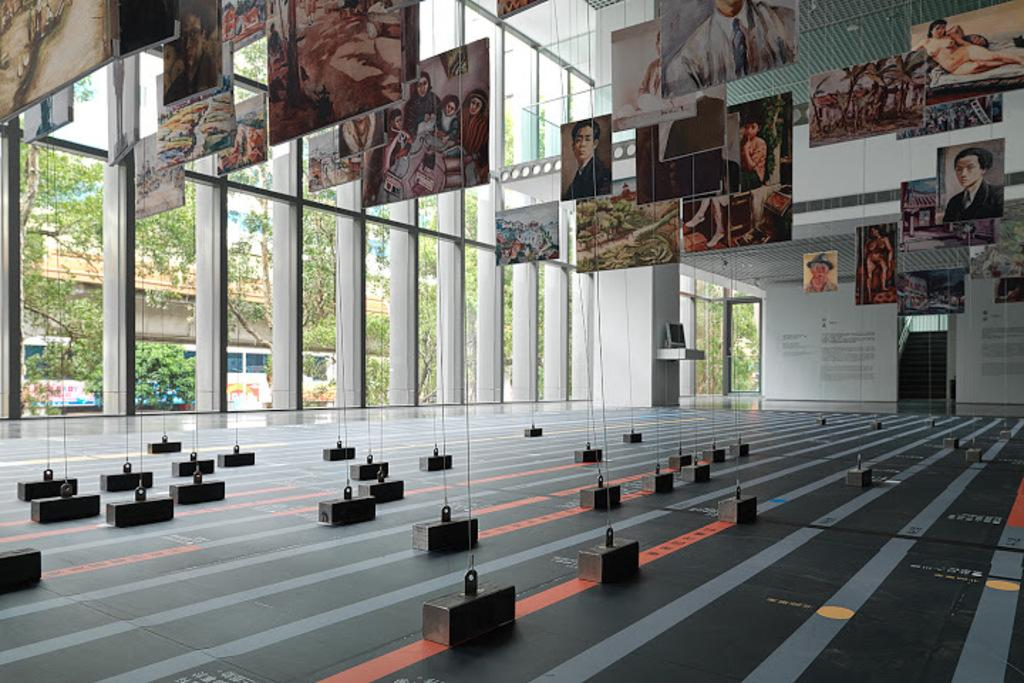What objects are hanging from the ceiling in the image? There are weights hanging from the ceiling in the image. Where are the weights located in relation to the floor? The weights are on the floor in the image. What type of artwork can be seen in the image? There are paintings hanging in the image. What type of windows are present in the image? There are glass windows in the image. What can be seen through the glass windows? Trees are visible behind the glass windows. What direction is the wind blowing in the image? There is no wind present in the image; it is a still scene with weights, paintings, and glass windows. Is there a river visible in the image? No, there is no river present in the image; only trees are visible through the glass windows. 